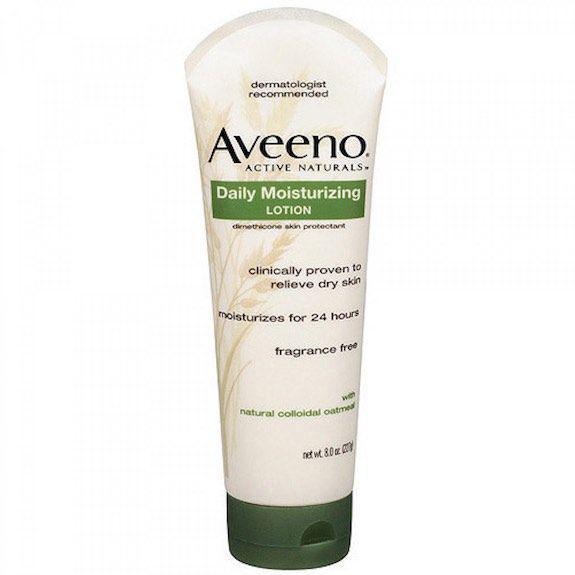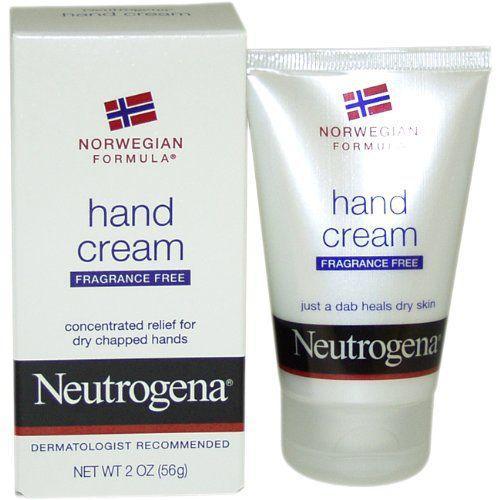The first image is the image on the left, the second image is the image on the right. Considering the images on both sides, is "Two tubes of body moisturing products are stood on cap end, one in each image, one of them beside a box in which the product may be sold." valid? Answer yes or no. Yes. The first image is the image on the left, the second image is the image on the right. For the images displayed, is the sentence "In at least one image, there is a green tube with a white cap next to a green box packaging" factually correct? Answer yes or no. No. 